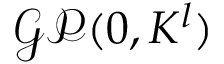Convert formula to latex. <formula><loc_0><loc_0><loc_500><loc_500>\mathcal { G P } ( 0 , K ^ { l } )</formula> 